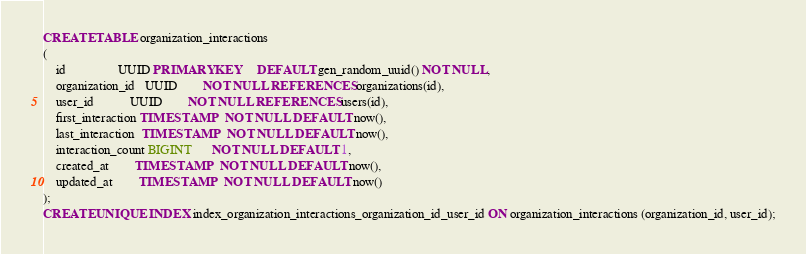Convert code to text. <code><loc_0><loc_0><loc_500><loc_500><_SQL_>CREATE TABLE organization_interactions
(
    id                UUID PRIMARY KEY     DEFAULT gen_random_uuid() NOT NULL,
    organization_id   UUID        NOT NULL REFERENCES organizations(id),
    user_id           UUID        NOT NULL REFERENCES users(id),
    first_interaction TIMESTAMP   NOT NULL DEFAULT now(),
    last_interaction  TIMESTAMP   NOT NULL DEFAULT now(),
    interaction_count BIGINT      NOT NULL DEFAULT 1,
    created_at        TIMESTAMP   NOT NULL DEFAULT now(),
    updated_at        TIMESTAMP   NOT NULL DEFAULT now()
);
CREATE UNIQUE INDEX index_organization_interactions_organization_id_user_id ON organization_interactions (organization_id, user_id);
</code> 